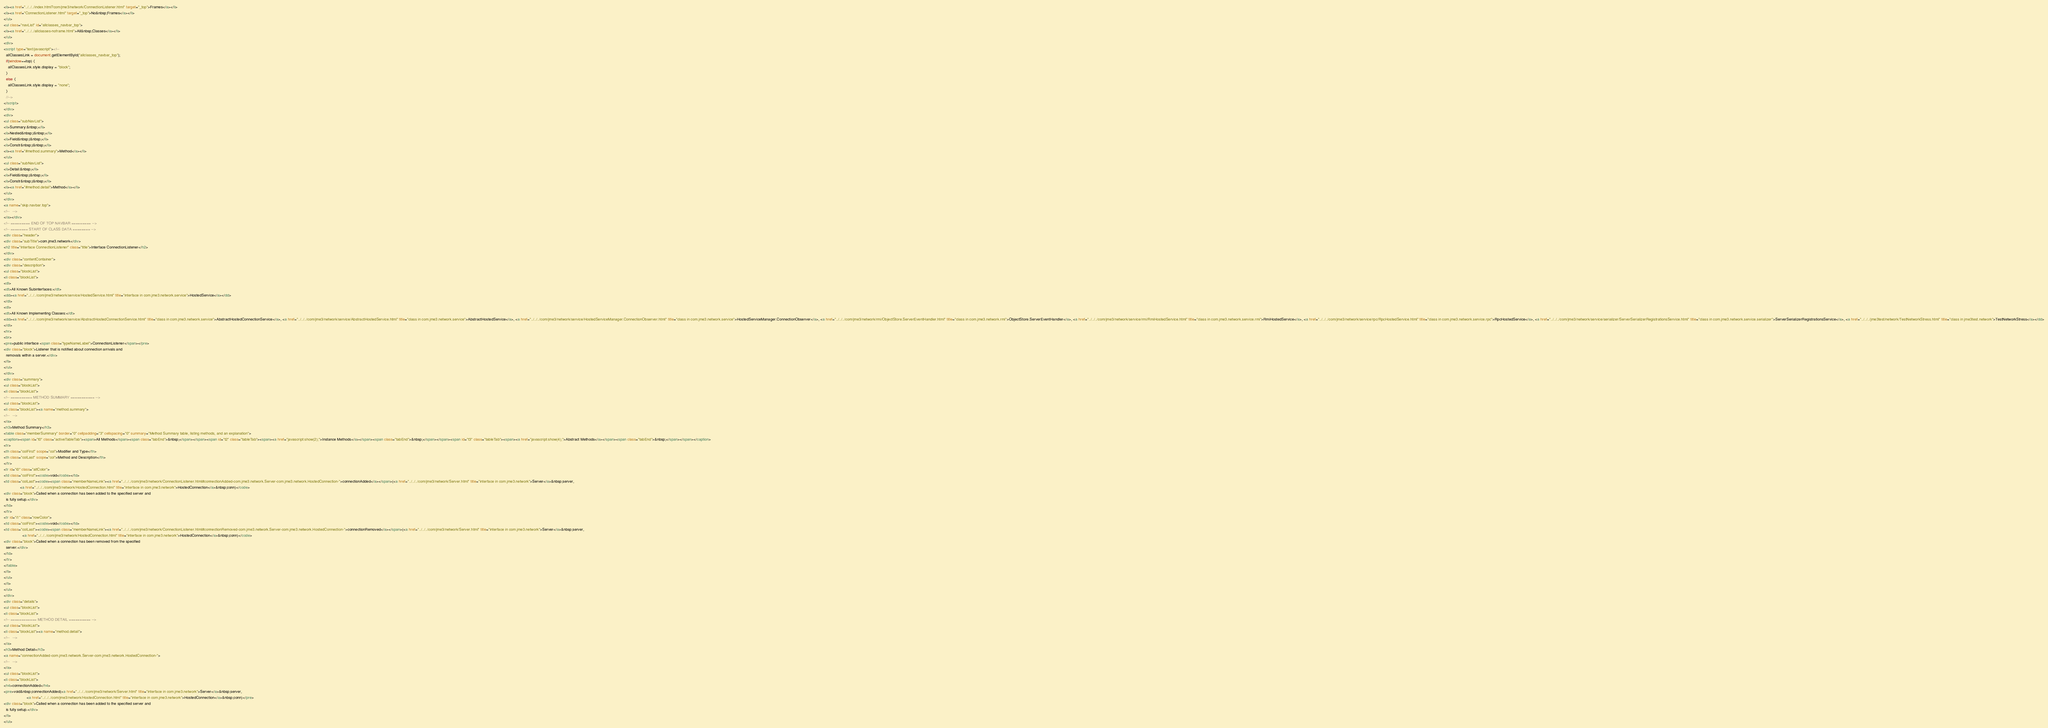Convert code to text. <code><loc_0><loc_0><loc_500><loc_500><_HTML_><li><a href="../../../index.html?com/jme3/network/ConnectionListener.html" target="_top">Frames</a></li>
<li><a href="ConnectionListener.html" target="_top">No&nbsp;Frames</a></li>
</ul>
<ul class="navList" id="allclasses_navbar_top">
<li><a href="../../../allclasses-noframe.html">All&nbsp;Classes</a></li>
</ul>
<div>
<script type="text/javascript"><!--
  allClassesLink = document.getElementById("allclasses_navbar_top");
  if(window==top) {
    allClassesLink.style.display = "block";
  }
  else {
    allClassesLink.style.display = "none";
  }
  //-->
</script>
</div>
<div>
<ul class="subNavList">
<li>Summary:&nbsp;</li>
<li>Nested&nbsp;|&nbsp;</li>
<li>Field&nbsp;|&nbsp;</li>
<li>Constr&nbsp;|&nbsp;</li>
<li><a href="#method.summary">Method</a></li>
</ul>
<ul class="subNavList">
<li>Detail:&nbsp;</li>
<li>Field&nbsp;|&nbsp;</li>
<li>Constr&nbsp;|&nbsp;</li>
<li><a href="#method.detail">Method</a></li>
</ul>
</div>
<a name="skip.navbar.top">
<!--   -->
</a></div>
<!-- ========= END OF TOP NAVBAR ========= -->
<!-- ======== START OF CLASS DATA ======== -->
<div class="header">
<div class="subTitle">com.jme3.network</div>
<h2 title="Interface ConnectionListener" class="title">Interface ConnectionListener</h2>
</div>
<div class="contentContainer">
<div class="description">
<ul class="blockList">
<li class="blockList">
<dl>
<dt>All Known Subinterfaces:</dt>
<dd><a href="../../../com/jme3/network/service/HostedService.html" title="interface in com.jme3.network.service">HostedService</a></dd>
</dl>
<dl>
<dt>All Known Implementing Classes:</dt>
<dd><a href="../../../com/jme3/network/service/AbstractHostedConnectionService.html" title="class in com.jme3.network.service">AbstractHostedConnectionService</a>, <a href="../../../com/jme3/network/service/AbstractHostedService.html" title="class in com.jme3.network.service">AbstractHostedService</a>, <a href="../../../com/jme3/network/service/HostedServiceManager.ConnectionObserver.html" title="class in com.jme3.network.service">HostedServiceManager.ConnectionObserver</a>, <a href="../../../com/jme3/network/rmi/ObjectStore.ServerEventHandler.html" title="class in com.jme3.network.rmi">ObjectStore.ServerEventHandler</a>, <a href="../../../com/jme3/network/service/rmi/RmiHostedService.html" title="class in com.jme3.network.service.rmi">RmiHostedService</a>, <a href="../../../com/jme3/network/service/rpc/RpcHostedService.html" title="class in com.jme3.network.service.rpc">RpcHostedService</a>, <a href="../../../com/jme3/network/service/serializer/ServerSerializerRegistrationsService.html" title="class in com.jme3.network.service.serializer">ServerSerializerRegistrationsService</a>, <a href="../../../jme3test/network/TestNetworkStress.html" title="class in jme3test.network">TestNetworkStress</a></dd>
</dl>
<hr>
<br>
<pre>public interface <span class="typeNameLabel">ConnectionListener</span></pre>
<div class="block">Listener that is notified about connection arrivals and
  removals within a server.</div>
</li>
</ul>
</div>
<div class="summary">
<ul class="blockList">
<li class="blockList">
<!-- ========== METHOD SUMMARY =========== -->
<ul class="blockList">
<li class="blockList"><a name="method.summary">
<!--   -->
</a>
<h3>Method Summary</h3>
<table class="memberSummary" border="0" cellpadding="3" cellspacing="0" summary="Method Summary table, listing methods, and an explanation">
<caption><span id="t0" class="activeTableTab"><span>All Methods</span><span class="tabEnd">&nbsp;</span></span><span id="t2" class="tableTab"><span><a href="javascript:show(2);">Instance Methods</a></span><span class="tabEnd">&nbsp;</span></span><span id="t3" class="tableTab"><span><a href="javascript:show(4);">Abstract Methods</a></span><span class="tabEnd">&nbsp;</span></span></caption>
<tr>
<th class="colFirst" scope="col">Modifier and Type</th>
<th class="colLast" scope="col">Method and Description</th>
</tr>
<tr id="i0" class="altColor">
<td class="colFirst"><code>void</code></td>
<td class="colLast"><code><span class="memberNameLink"><a href="../../../com/jme3/network/ConnectionListener.html#connectionAdded-com.jme3.network.Server-com.jme3.network.HostedConnection-">connectionAdded</a></span>(<a href="../../../com/jme3/network/Server.html" title="interface in com.jme3.network">Server</a>&nbsp;server,
               <a href="../../../com/jme3/network/HostedConnection.html" title="interface in com.jme3.network">HostedConnection</a>&nbsp;conn)</code>
<div class="block">Called when a connection has been added to the specified server and
  is fully setup.</div>
</td>
</tr>
<tr id="i1" class="rowColor">
<td class="colFirst"><code>void</code></td>
<td class="colLast"><code><span class="memberNameLink"><a href="../../../com/jme3/network/ConnectionListener.html#connectionRemoved-com.jme3.network.Server-com.jme3.network.HostedConnection-">connectionRemoved</a></span>(<a href="../../../com/jme3/network/Server.html" title="interface in com.jme3.network">Server</a>&nbsp;server,
                 <a href="../../../com/jme3/network/HostedConnection.html" title="interface in com.jme3.network">HostedConnection</a>&nbsp;conn)</code>
<div class="block">Called when a connection has been removed from the specified
  server.</div>
</td>
</tr>
</table>
</li>
</ul>
</li>
</ul>
</div>
<div class="details">
<ul class="blockList">
<li class="blockList">
<!-- ============ METHOD DETAIL ========== -->
<ul class="blockList">
<li class="blockList"><a name="method.detail">
<!--   -->
</a>
<h3>Method Detail</h3>
<a name="connectionAdded-com.jme3.network.Server-com.jme3.network.HostedConnection-">
<!--   -->
</a>
<ul class="blockList">
<li class="blockList">
<h4>connectionAdded</h4>
<pre>void&nbsp;connectionAdded(<a href="../../../com/jme3/network/Server.html" title="interface in com.jme3.network">Server</a>&nbsp;server,
                     <a href="../../../com/jme3/network/HostedConnection.html" title="interface in com.jme3.network">HostedConnection</a>&nbsp;conn)</pre>
<div class="block">Called when a connection has been added to the specified server and
  is fully setup.</div>
</li>
</ul></code> 